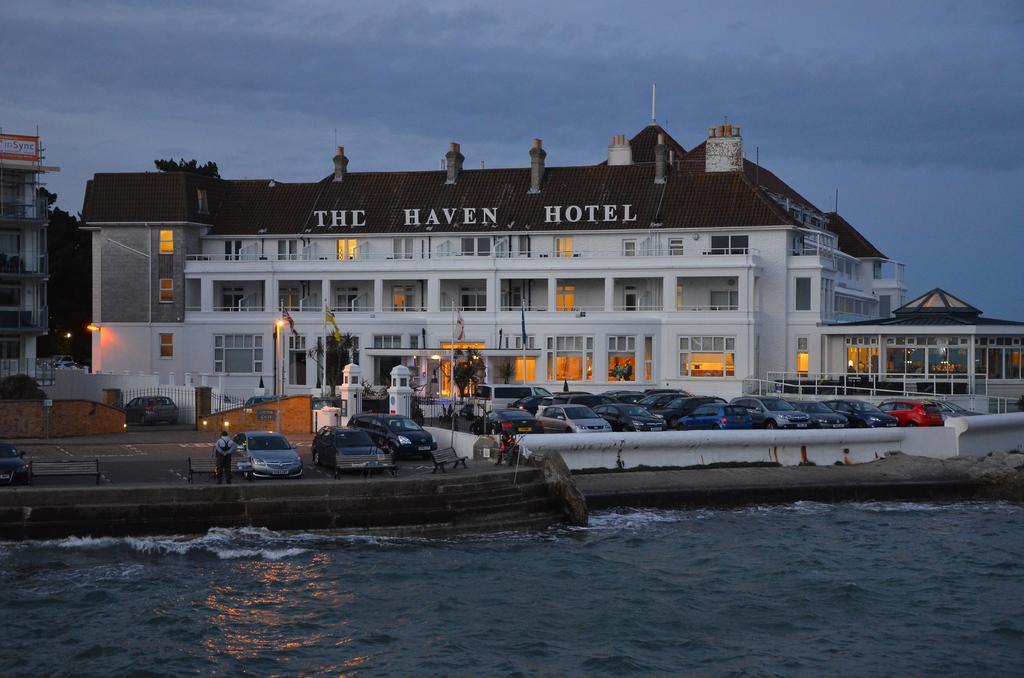Could you give a brief overview of what you see in this image? In this image I can see water, number of cars, benches, white colour buildings and I can see few flags. I can also see a person is standing over here and in background I can see few lights, trees, the sky and I can see something is written over here. 